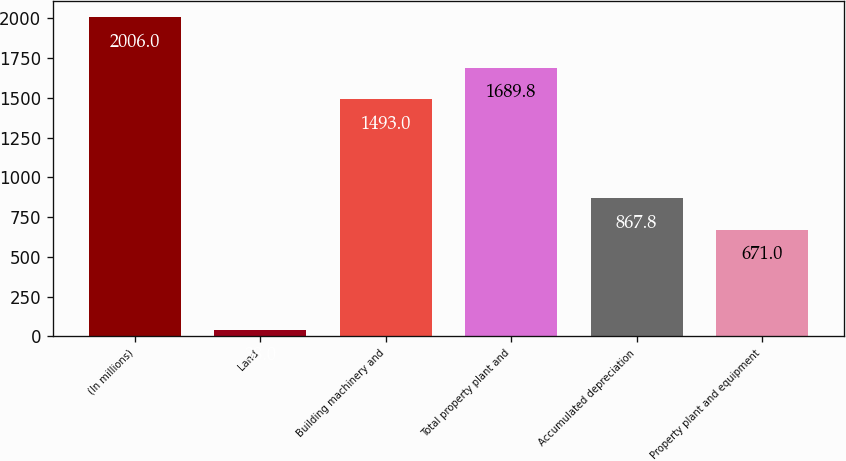<chart> <loc_0><loc_0><loc_500><loc_500><bar_chart><fcel>(In millions)<fcel>Land<fcel>Building machinery and<fcel>Total property plant and<fcel>Accumulated depreciation<fcel>Property plant and equipment<nl><fcel>2006<fcel>38<fcel>1493<fcel>1689.8<fcel>867.8<fcel>671<nl></chart> 